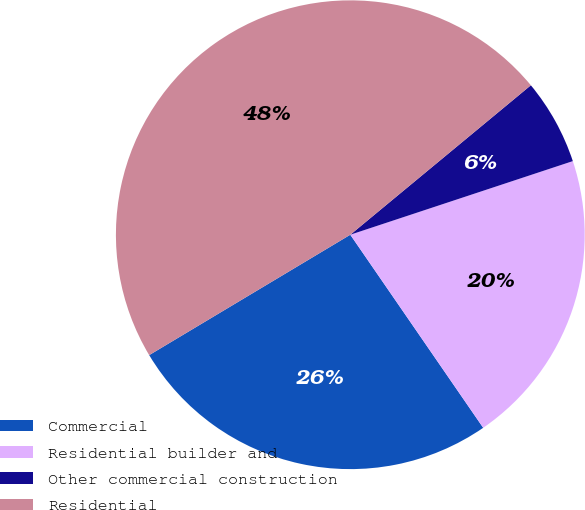Convert chart to OTSL. <chart><loc_0><loc_0><loc_500><loc_500><pie_chart><fcel>Commercial<fcel>Residential builder and<fcel>Other commercial construction<fcel>Residential<nl><fcel>26.01%<fcel>20.49%<fcel>5.92%<fcel>47.58%<nl></chart> 